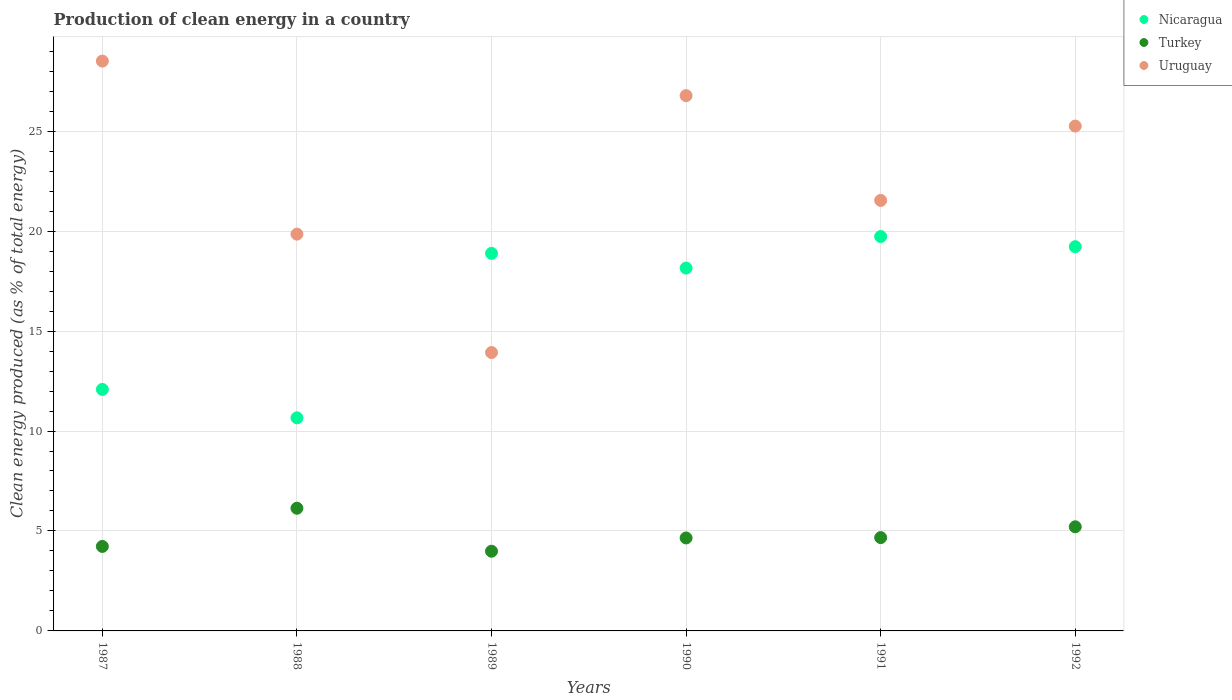Is the number of dotlines equal to the number of legend labels?
Provide a short and direct response. Yes. What is the percentage of clean energy produced in Nicaragua in 1987?
Make the answer very short. 12.08. Across all years, what is the maximum percentage of clean energy produced in Uruguay?
Your response must be concise. 28.51. Across all years, what is the minimum percentage of clean energy produced in Uruguay?
Provide a short and direct response. 13.93. In which year was the percentage of clean energy produced in Uruguay maximum?
Provide a short and direct response. 1987. In which year was the percentage of clean energy produced in Nicaragua minimum?
Give a very brief answer. 1988. What is the total percentage of clean energy produced in Uruguay in the graph?
Your answer should be very brief. 135.84. What is the difference between the percentage of clean energy produced in Nicaragua in 1989 and that in 1990?
Provide a succinct answer. 0.74. What is the difference between the percentage of clean energy produced in Nicaragua in 1990 and the percentage of clean energy produced in Uruguay in 1987?
Make the answer very short. -10.35. What is the average percentage of clean energy produced in Uruguay per year?
Make the answer very short. 22.64. In the year 1990, what is the difference between the percentage of clean energy produced in Nicaragua and percentage of clean energy produced in Uruguay?
Your answer should be very brief. -8.62. In how many years, is the percentage of clean energy produced in Turkey greater than 11 %?
Your response must be concise. 0. What is the ratio of the percentage of clean energy produced in Uruguay in 1987 to that in 1989?
Your answer should be compact. 2.05. Is the percentage of clean energy produced in Nicaragua in 1987 less than that in 1989?
Ensure brevity in your answer.  Yes. What is the difference between the highest and the second highest percentage of clean energy produced in Uruguay?
Your response must be concise. 1.73. What is the difference between the highest and the lowest percentage of clean energy produced in Turkey?
Offer a terse response. 2.15. Is it the case that in every year, the sum of the percentage of clean energy produced in Uruguay and percentage of clean energy produced in Turkey  is greater than the percentage of clean energy produced in Nicaragua?
Your answer should be compact. No. Does the percentage of clean energy produced in Nicaragua monotonically increase over the years?
Keep it short and to the point. No. Is the percentage of clean energy produced in Nicaragua strictly greater than the percentage of clean energy produced in Uruguay over the years?
Your answer should be very brief. No. Is the percentage of clean energy produced in Nicaragua strictly less than the percentage of clean energy produced in Turkey over the years?
Your response must be concise. No. Does the graph contain grids?
Provide a succinct answer. Yes. Where does the legend appear in the graph?
Provide a succinct answer. Top right. How many legend labels are there?
Provide a short and direct response. 3. What is the title of the graph?
Make the answer very short. Production of clean energy in a country. Does "Jordan" appear as one of the legend labels in the graph?
Provide a short and direct response. No. What is the label or title of the Y-axis?
Make the answer very short. Clean energy produced (as % of total energy). What is the Clean energy produced (as % of total energy) of Nicaragua in 1987?
Your answer should be compact. 12.08. What is the Clean energy produced (as % of total energy) in Turkey in 1987?
Ensure brevity in your answer.  4.23. What is the Clean energy produced (as % of total energy) in Uruguay in 1987?
Offer a very short reply. 28.51. What is the Clean energy produced (as % of total energy) in Nicaragua in 1988?
Your response must be concise. 10.66. What is the Clean energy produced (as % of total energy) in Turkey in 1988?
Your response must be concise. 6.14. What is the Clean energy produced (as % of total energy) of Uruguay in 1988?
Offer a terse response. 19.85. What is the Clean energy produced (as % of total energy) in Nicaragua in 1989?
Provide a short and direct response. 18.89. What is the Clean energy produced (as % of total energy) of Turkey in 1989?
Your answer should be compact. 3.99. What is the Clean energy produced (as % of total energy) in Uruguay in 1989?
Give a very brief answer. 13.93. What is the Clean energy produced (as % of total energy) of Nicaragua in 1990?
Offer a very short reply. 18.15. What is the Clean energy produced (as % of total energy) in Turkey in 1990?
Make the answer very short. 4.65. What is the Clean energy produced (as % of total energy) of Uruguay in 1990?
Ensure brevity in your answer.  26.78. What is the Clean energy produced (as % of total energy) in Nicaragua in 1991?
Offer a very short reply. 19.73. What is the Clean energy produced (as % of total energy) in Turkey in 1991?
Ensure brevity in your answer.  4.67. What is the Clean energy produced (as % of total energy) in Uruguay in 1991?
Your answer should be compact. 21.54. What is the Clean energy produced (as % of total energy) of Nicaragua in 1992?
Keep it short and to the point. 19.22. What is the Clean energy produced (as % of total energy) of Turkey in 1992?
Your response must be concise. 5.21. What is the Clean energy produced (as % of total energy) in Uruguay in 1992?
Ensure brevity in your answer.  25.25. Across all years, what is the maximum Clean energy produced (as % of total energy) of Nicaragua?
Your response must be concise. 19.73. Across all years, what is the maximum Clean energy produced (as % of total energy) in Turkey?
Your answer should be very brief. 6.14. Across all years, what is the maximum Clean energy produced (as % of total energy) of Uruguay?
Give a very brief answer. 28.51. Across all years, what is the minimum Clean energy produced (as % of total energy) in Nicaragua?
Your answer should be very brief. 10.66. Across all years, what is the minimum Clean energy produced (as % of total energy) in Turkey?
Provide a short and direct response. 3.99. Across all years, what is the minimum Clean energy produced (as % of total energy) of Uruguay?
Your answer should be compact. 13.93. What is the total Clean energy produced (as % of total energy) of Nicaragua in the graph?
Provide a short and direct response. 98.73. What is the total Clean energy produced (as % of total energy) of Turkey in the graph?
Provide a short and direct response. 28.88. What is the total Clean energy produced (as % of total energy) of Uruguay in the graph?
Your answer should be compact. 135.84. What is the difference between the Clean energy produced (as % of total energy) in Nicaragua in 1987 and that in 1988?
Provide a short and direct response. 1.42. What is the difference between the Clean energy produced (as % of total energy) of Turkey in 1987 and that in 1988?
Offer a terse response. -1.91. What is the difference between the Clean energy produced (as % of total energy) in Uruguay in 1987 and that in 1988?
Provide a short and direct response. 8.66. What is the difference between the Clean energy produced (as % of total energy) of Nicaragua in 1987 and that in 1989?
Offer a terse response. -6.81. What is the difference between the Clean energy produced (as % of total energy) in Turkey in 1987 and that in 1989?
Make the answer very short. 0.24. What is the difference between the Clean energy produced (as % of total energy) in Uruguay in 1987 and that in 1989?
Make the answer very short. 14.58. What is the difference between the Clean energy produced (as % of total energy) of Nicaragua in 1987 and that in 1990?
Provide a succinct answer. -6.07. What is the difference between the Clean energy produced (as % of total energy) in Turkey in 1987 and that in 1990?
Ensure brevity in your answer.  -0.42. What is the difference between the Clean energy produced (as % of total energy) of Uruguay in 1987 and that in 1990?
Keep it short and to the point. 1.73. What is the difference between the Clean energy produced (as % of total energy) in Nicaragua in 1987 and that in 1991?
Your response must be concise. -7.65. What is the difference between the Clean energy produced (as % of total energy) of Turkey in 1987 and that in 1991?
Give a very brief answer. -0.44. What is the difference between the Clean energy produced (as % of total energy) of Uruguay in 1987 and that in 1991?
Give a very brief answer. 6.97. What is the difference between the Clean energy produced (as % of total energy) in Nicaragua in 1987 and that in 1992?
Your response must be concise. -7.14. What is the difference between the Clean energy produced (as % of total energy) in Turkey in 1987 and that in 1992?
Make the answer very short. -0.98. What is the difference between the Clean energy produced (as % of total energy) of Uruguay in 1987 and that in 1992?
Provide a succinct answer. 3.25. What is the difference between the Clean energy produced (as % of total energy) in Nicaragua in 1988 and that in 1989?
Make the answer very short. -8.23. What is the difference between the Clean energy produced (as % of total energy) of Turkey in 1988 and that in 1989?
Make the answer very short. 2.15. What is the difference between the Clean energy produced (as % of total energy) in Uruguay in 1988 and that in 1989?
Your answer should be very brief. 5.92. What is the difference between the Clean energy produced (as % of total energy) in Nicaragua in 1988 and that in 1990?
Provide a succinct answer. -7.49. What is the difference between the Clean energy produced (as % of total energy) of Turkey in 1988 and that in 1990?
Your answer should be compact. 1.49. What is the difference between the Clean energy produced (as % of total energy) in Uruguay in 1988 and that in 1990?
Your answer should be compact. -6.93. What is the difference between the Clean energy produced (as % of total energy) in Nicaragua in 1988 and that in 1991?
Your answer should be very brief. -9.07. What is the difference between the Clean energy produced (as % of total energy) in Turkey in 1988 and that in 1991?
Keep it short and to the point. 1.47. What is the difference between the Clean energy produced (as % of total energy) in Uruguay in 1988 and that in 1991?
Your response must be concise. -1.69. What is the difference between the Clean energy produced (as % of total energy) of Nicaragua in 1988 and that in 1992?
Your answer should be compact. -8.56. What is the difference between the Clean energy produced (as % of total energy) in Turkey in 1988 and that in 1992?
Provide a succinct answer. 0.93. What is the difference between the Clean energy produced (as % of total energy) of Uruguay in 1988 and that in 1992?
Your answer should be compact. -5.41. What is the difference between the Clean energy produced (as % of total energy) of Nicaragua in 1989 and that in 1990?
Your answer should be very brief. 0.74. What is the difference between the Clean energy produced (as % of total energy) of Turkey in 1989 and that in 1990?
Ensure brevity in your answer.  -0.66. What is the difference between the Clean energy produced (as % of total energy) of Uruguay in 1989 and that in 1990?
Your answer should be very brief. -12.85. What is the difference between the Clean energy produced (as % of total energy) in Nicaragua in 1989 and that in 1991?
Keep it short and to the point. -0.84. What is the difference between the Clean energy produced (as % of total energy) of Turkey in 1989 and that in 1991?
Make the answer very short. -0.68. What is the difference between the Clean energy produced (as % of total energy) in Uruguay in 1989 and that in 1991?
Give a very brief answer. -7.61. What is the difference between the Clean energy produced (as % of total energy) in Nicaragua in 1989 and that in 1992?
Make the answer very short. -0.33. What is the difference between the Clean energy produced (as % of total energy) in Turkey in 1989 and that in 1992?
Your answer should be compact. -1.22. What is the difference between the Clean energy produced (as % of total energy) in Uruguay in 1989 and that in 1992?
Your response must be concise. -11.33. What is the difference between the Clean energy produced (as % of total energy) in Nicaragua in 1990 and that in 1991?
Provide a short and direct response. -1.58. What is the difference between the Clean energy produced (as % of total energy) in Turkey in 1990 and that in 1991?
Your response must be concise. -0.02. What is the difference between the Clean energy produced (as % of total energy) of Uruguay in 1990 and that in 1991?
Keep it short and to the point. 5.24. What is the difference between the Clean energy produced (as % of total energy) in Nicaragua in 1990 and that in 1992?
Make the answer very short. -1.07. What is the difference between the Clean energy produced (as % of total energy) of Turkey in 1990 and that in 1992?
Make the answer very short. -0.56. What is the difference between the Clean energy produced (as % of total energy) of Uruguay in 1990 and that in 1992?
Your response must be concise. 1.52. What is the difference between the Clean energy produced (as % of total energy) in Nicaragua in 1991 and that in 1992?
Keep it short and to the point. 0.51. What is the difference between the Clean energy produced (as % of total energy) of Turkey in 1991 and that in 1992?
Ensure brevity in your answer.  -0.54. What is the difference between the Clean energy produced (as % of total energy) of Uruguay in 1991 and that in 1992?
Your answer should be compact. -3.72. What is the difference between the Clean energy produced (as % of total energy) in Nicaragua in 1987 and the Clean energy produced (as % of total energy) in Turkey in 1988?
Give a very brief answer. 5.94. What is the difference between the Clean energy produced (as % of total energy) in Nicaragua in 1987 and the Clean energy produced (as % of total energy) in Uruguay in 1988?
Offer a very short reply. -7.77. What is the difference between the Clean energy produced (as % of total energy) in Turkey in 1987 and the Clean energy produced (as % of total energy) in Uruguay in 1988?
Make the answer very short. -15.62. What is the difference between the Clean energy produced (as % of total energy) in Nicaragua in 1987 and the Clean energy produced (as % of total energy) in Turkey in 1989?
Provide a short and direct response. 8.09. What is the difference between the Clean energy produced (as % of total energy) in Nicaragua in 1987 and the Clean energy produced (as % of total energy) in Uruguay in 1989?
Provide a short and direct response. -1.85. What is the difference between the Clean energy produced (as % of total energy) in Turkey in 1987 and the Clean energy produced (as % of total energy) in Uruguay in 1989?
Your answer should be very brief. -9.7. What is the difference between the Clean energy produced (as % of total energy) in Nicaragua in 1987 and the Clean energy produced (as % of total energy) in Turkey in 1990?
Your answer should be compact. 7.43. What is the difference between the Clean energy produced (as % of total energy) in Nicaragua in 1987 and the Clean energy produced (as % of total energy) in Uruguay in 1990?
Provide a succinct answer. -14.7. What is the difference between the Clean energy produced (as % of total energy) in Turkey in 1987 and the Clean energy produced (as % of total energy) in Uruguay in 1990?
Provide a succinct answer. -22.55. What is the difference between the Clean energy produced (as % of total energy) in Nicaragua in 1987 and the Clean energy produced (as % of total energy) in Turkey in 1991?
Provide a short and direct response. 7.41. What is the difference between the Clean energy produced (as % of total energy) in Nicaragua in 1987 and the Clean energy produced (as % of total energy) in Uruguay in 1991?
Your answer should be compact. -9.46. What is the difference between the Clean energy produced (as % of total energy) of Turkey in 1987 and the Clean energy produced (as % of total energy) of Uruguay in 1991?
Make the answer very short. -17.31. What is the difference between the Clean energy produced (as % of total energy) in Nicaragua in 1987 and the Clean energy produced (as % of total energy) in Turkey in 1992?
Offer a very short reply. 6.87. What is the difference between the Clean energy produced (as % of total energy) of Nicaragua in 1987 and the Clean energy produced (as % of total energy) of Uruguay in 1992?
Make the answer very short. -13.17. What is the difference between the Clean energy produced (as % of total energy) in Turkey in 1987 and the Clean energy produced (as % of total energy) in Uruguay in 1992?
Offer a terse response. -21.03. What is the difference between the Clean energy produced (as % of total energy) of Nicaragua in 1988 and the Clean energy produced (as % of total energy) of Turkey in 1989?
Your response must be concise. 6.67. What is the difference between the Clean energy produced (as % of total energy) in Nicaragua in 1988 and the Clean energy produced (as % of total energy) in Uruguay in 1989?
Ensure brevity in your answer.  -3.27. What is the difference between the Clean energy produced (as % of total energy) in Turkey in 1988 and the Clean energy produced (as % of total energy) in Uruguay in 1989?
Offer a very short reply. -7.79. What is the difference between the Clean energy produced (as % of total energy) in Nicaragua in 1988 and the Clean energy produced (as % of total energy) in Turkey in 1990?
Keep it short and to the point. 6.01. What is the difference between the Clean energy produced (as % of total energy) in Nicaragua in 1988 and the Clean energy produced (as % of total energy) in Uruguay in 1990?
Give a very brief answer. -16.12. What is the difference between the Clean energy produced (as % of total energy) in Turkey in 1988 and the Clean energy produced (as % of total energy) in Uruguay in 1990?
Provide a short and direct response. -20.64. What is the difference between the Clean energy produced (as % of total energy) in Nicaragua in 1988 and the Clean energy produced (as % of total energy) in Turkey in 1991?
Provide a short and direct response. 5.99. What is the difference between the Clean energy produced (as % of total energy) in Nicaragua in 1988 and the Clean energy produced (as % of total energy) in Uruguay in 1991?
Provide a succinct answer. -10.88. What is the difference between the Clean energy produced (as % of total energy) of Turkey in 1988 and the Clean energy produced (as % of total energy) of Uruguay in 1991?
Your response must be concise. -15.4. What is the difference between the Clean energy produced (as % of total energy) in Nicaragua in 1988 and the Clean energy produced (as % of total energy) in Turkey in 1992?
Ensure brevity in your answer.  5.45. What is the difference between the Clean energy produced (as % of total energy) in Nicaragua in 1988 and the Clean energy produced (as % of total energy) in Uruguay in 1992?
Offer a very short reply. -14.59. What is the difference between the Clean energy produced (as % of total energy) of Turkey in 1988 and the Clean energy produced (as % of total energy) of Uruguay in 1992?
Your response must be concise. -19.12. What is the difference between the Clean energy produced (as % of total energy) of Nicaragua in 1989 and the Clean energy produced (as % of total energy) of Turkey in 1990?
Provide a short and direct response. 14.24. What is the difference between the Clean energy produced (as % of total energy) of Nicaragua in 1989 and the Clean energy produced (as % of total energy) of Uruguay in 1990?
Make the answer very short. -7.89. What is the difference between the Clean energy produced (as % of total energy) of Turkey in 1989 and the Clean energy produced (as % of total energy) of Uruguay in 1990?
Offer a terse response. -22.79. What is the difference between the Clean energy produced (as % of total energy) in Nicaragua in 1989 and the Clean energy produced (as % of total energy) in Turkey in 1991?
Ensure brevity in your answer.  14.22. What is the difference between the Clean energy produced (as % of total energy) of Nicaragua in 1989 and the Clean energy produced (as % of total energy) of Uruguay in 1991?
Your answer should be compact. -2.65. What is the difference between the Clean energy produced (as % of total energy) in Turkey in 1989 and the Clean energy produced (as % of total energy) in Uruguay in 1991?
Your answer should be compact. -17.55. What is the difference between the Clean energy produced (as % of total energy) in Nicaragua in 1989 and the Clean energy produced (as % of total energy) in Turkey in 1992?
Offer a very short reply. 13.68. What is the difference between the Clean energy produced (as % of total energy) in Nicaragua in 1989 and the Clean energy produced (as % of total energy) in Uruguay in 1992?
Ensure brevity in your answer.  -6.37. What is the difference between the Clean energy produced (as % of total energy) in Turkey in 1989 and the Clean energy produced (as % of total energy) in Uruguay in 1992?
Your answer should be compact. -21.27. What is the difference between the Clean energy produced (as % of total energy) of Nicaragua in 1990 and the Clean energy produced (as % of total energy) of Turkey in 1991?
Your answer should be very brief. 13.48. What is the difference between the Clean energy produced (as % of total energy) of Nicaragua in 1990 and the Clean energy produced (as % of total energy) of Uruguay in 1991?
Ensure brevity in your answer.  -3.38. What is the difference between the Clean energy produced (as % of total energy) of Turkey in 1990 and the Clean energy produced (as % of total energy) of Uruguay in 1991?
Your answer should be compact. -16.88. What is the difference between the Clean energy produced (as % of total energy) in Nicaragua in 1990 and the Clean energy produced (as % of total energy) in Turkey in 1992?
Offer a terse response. 12.94. What is the difference between the Clean energy produced (as % of total energy) in Nicaragua in 1990 and the Clean energy produced (as % of total energy) in Uruguay in 1992?
Your answer should be very brief. -7.1. What is the difference between the Clean energy produced (as % of total energy) of Turkey in 1990 and the Clean energy produced (as % of total energy) of Uruguay in 1992?
Offer a very short reply. -20.6. What is the difference between the Clean energy produced (as % of total energy) of Nicaragua in 1991 and the Clean energy produced (as % of total energy) of Turkey in 1992?
Keep it short and to the point. 14.52. What is the difference between the Clean energy produced (as % of total energy) of Nicaragua in 1991 and the Clean energy produced (as % of total energy) of Uruguay in 1992?
Your answer should be very brief. -5.52. What is the difference between the Clean energy produced (as % of total energy) of Turkey in 1991 and the Clean energy produced (as % of total energy) of Uruguay in 1992?
Keep it short and to the point. -20.59. What is the average Clean energy produced (as % of total energy) of Nicaragua per year?
Your answer should be very brief. 16.45. What is the average Clean energy produced (as % of total energy) of Turkey per year?
Your answer should be compact. 4.81. What is the average Clean energy produced (as % of total energy) in Uruguay per year?
Give a very brief answer. 22.64. In the year 1987, what is the difference between the Clean energy produced (as % of total energy) of Nicaragua and Clean energy produced (as % of total energy) of Turkey?
Provide a succinct answer. 7.85. In the year 1987, what is the difference between the Clean energy produced (as % of total energy) of Nicaragua and Clean energy produced (as % of total energy) of Uruguay?
Offer a very short reply. -16.43. In the year 1987, what is the difference between the Clean energy produced (as % of total energy) in Turkey and Clean energy produced (as % of total energy) in Uruguay?
Provide a succinct answer. -24.28. In the year 1988, what is the difference between the Clean energy produced (as % of total energy) in Nicaragua and Clean energy produced (as % of total energy) in Turkey?
Give a very brief answer. 4.52. In the year 1988, what is the difference between the Clean energy produced (as % of total energy) of Nicaragua and Clean energy produced (as % of total energy) of Uruguay?
Provide a short and direct response. -9.19. In the year 1988, what is the difference between the Clean energy produced (as % of total energy) in Turkey and Clean energy produced (as % of total energy) in Uruguay?
Offer a very short reply. -13.71. In the year 1989, what is the difference between the Clean energy produced (as % of total energy) in Nicaragua and Clean energy produced (as % of total energy) in Turkey?
Your response must be concise. 14.9. In the year 1989, what is the difference between the Clean energy produced (as % of total energy) of Nicaragua and Clean energy produced (as % of total energy) of Uruguay?
Your answer should be very brief. 4.96. In the year 1989, what is the difference between the Clean energy produced (as % of total energy) of Turkey and Clean energy produced (as % of total energy) of Uruguay?
Give a very brief answer. -9.94. In the year 1990, what is the difference between the Clean energy produced (as % of total energy) of Nicaragua and Clean energy produced (as % of total energy) of Turkey?
Offer a very short reply. 13.5. In the year 1990, what is the difference between the Clean energy produced (as % of total energy) of Nicaragua and Clean energy produced (as % of total energy) of Uruguay?
Give a very brief answer. -8.62. In the year 1990, what is the difference between the Clean energy produced (as % of total energy) of Turkey and Clean energy produced (as % of total energy) of Uruguay?
Give a very brief answer. -22.13. In the year 1991, what is the difference between the Clean energy produced (as % of total energy) of Nicaragua and Clean energy produced (as % of total energy) of Turkey?
Your response must be concise. 15.06. In the year 1991, what is the difference between the Clean energy produced (as % of total energy) of Nicaragua and Clean energy produced (as % of total energy) of Uruguay?
Provide a succinct answer. -1.81. In the year 1991, what is the difference between the Clean energy produced (as % of total energy) of Turkey and Clean energy produced (as % of total energy) of Uruguay?
Offer a terse response. -16.87. In the year 1992, what is the difference between the Clean energy produced (as % of total energy) of Nicaragua and Clean energy produced (as % of total energy) of Turkey?
Give a very brief answer. 14.01. In the year 1992, what is the difference between the Clean energy produced (as % of total energy) of Nicaragua and Clean energy produced (as % of total energy) of Uruguay?
Your answer should be very brief. -6.03. In the year 1992, what is the difference between the Clean energy produced (as % of total energy) in Turkey and Clean energy produced (as % of total energy) in Uruguay?
Your answer should be compact. -20.04. What is the ratio of the Clean energy produced (as % of total energy) of Nicaragua in 1987 to that in 1988?
Ensure brevity in your answer.  1.13. What is the ratio of the Clean energy produced (as % of total energy) in Turkey in 1987 to that in 1988?
Provide a succinct answer. 0.69. What is the ratio of the Clean energy produced (as % of total energy) of Uruguay in 1987 to that in 1988?
Your answer should be very brief. 1.44. What is the ratio of the Clean energy produced (as % of total energy) of Nicaragua in 1987 to that in 1989?
Your answer should be very brief. 0.64. What is the ratio of the Clean energy produced (as % of total energy) in Turkey in 1987 to that in 1989?
Offer a terse response. 1.06. What is the ratio of the Clean energy produced (as % of total energy) of Uruguay in 1987 to that in 1989?
Ensure brevity in your answer.  2.05. What is the ratio of the Clean energy produced (as % of total energy) of Nicaragua in 1987 to that in 1990?
Offer a very short reply. 0.67. What is the ratio of the Clean energy produced (as % of total energy) of Turkey in 1987 to that in 1990?
Provide a short and direct response. 0.91. What is the ratio of the Clean energy produced (as % of total energy) of Uruguay in 1987 to that in 1990?
Keep it short and to the point. 1.06. What is the ratio of the Clean energy produced (as % of total energy) in Nicaragua in 1987 to that in 1991?
Make the answer very short. 0.61. What is the ratio of the Clean energy produced (as % of total energy) in Turkey in 1987 to that in 1991?
Keep it short and to the point. 0.91. What is the ratio of the Clean energy produced (as % of total energy) in Uruguay in 1987 to that in 1991?
Ensure brevity in your answer.  1.32. What is the ratio of the Clean energy produced (as % of total energy) in Nicaragua in 1987 to that in 1992?
Offer a very short reply. 0.63. What is the ratio of the Clean energy produced (as % of total energy) of Turkey in 1987 to that in 1992?
Keep it short and to the point. 0.81. What is the ratio of the Clean energy produced (as % of total energy) in Uruguay in 1987 to that in 1992?
Your response must be concise. 1.13. What is the ratio of the Clean energy produced (as % of total energy) in Nicaragua in 1988 to that in 1989?
Your response must be concise. 0.56. What is the ratio of the Clean energy produced (as % of total energy) of Turkey in 1988 to that in 1989?
Provide a short and direct response. 1.54. What is the ratio of the Clean energy produced (as % of total energy) of Uruguay in 1988 to that in 1989?
Your answer should be very brief. 1.43. What is the ratio of the Clean energy produced (as % of total energy) in Nicaragua in 1988 to that in 1990?
Provide a short and direct response. 0.59. What is the ratio of the Clean energy produced (as % of total energy) in Turkey in 1988 to that in 1990?
Give a very brief answer. 1.32. What is the ratio of the Clean energy produced (as % of total energy) of Uruguay in 1988 to that in 1990?
Make the answer very short. 0.74. What is the ratio of the Clean energy produced (as % of total energy) of Nicaragua in 1988 to that in 1991?
Your response must be concise. 0.54. What is the ratio of the Clean energy produced (as % of total energy) of Turkey in 1988 to that in 1991?
Your response must be concise. 1.31. What is the ratio of the Clean energy produced (as % of total energy) in Uruguay in 1988 to that in 1991?
Offer a terse response. 0.92. What is the ratio of the Clean energy produced (as % of total energy) in Nicaragua in 1988 to that in 1992?
Make the answer very short. 0.55. What is the ratio of the Clean energy produced (as % of total energy) of Turkey in 1988 to that in 1992?
Ensure brevity in your answer.  1.18. What is the ratio of the Clean energy produced (as % of total energy) of Uruguay in 1988 to that in 1992?
Provide a short and direct response. 0.79. What is the ratio of the Clean energy produced (as % of total energy) of Nicaragua in 1989 to that in 1990?
Provide a short and direct response. 1.04. What is the ratio of the Clean energy produced (as % of total energy) in Turkey in 1989 to that in 1990?
Make the answer very short. 0.86. What is the ratio of the Clean energy produced (as % of total energy) of Uruguay in 1989 to that in 1990?
Your answer should be compact. 0.52. What is the ratio of the Clean energy produced (as % of total energy) in Nicaragua in 1989 to that in 1991?
Your response must be concise. 0.96. What is the ratio of the Clean energy produced (as % of total energy) of Turkey in 1989 to that in 1991?
Offer a very short reply. 0.85. What is the ratio of the Clean energy produced (as % of total energy) of Uruguay in 1989 to that in 1991?
Provide a short and direct response. 0.65. What is the ratio of the Clean energy produced (as % of total energy) in Nicaragua in 1989 to that in 1992?
Offer a very short reply. 0.98. What is the ratio of the Clean energy produced (as % of total energy) in Turkey in 1989 to that in 1992?
Give a very brief answer. 0.77. What is the ratio of the Clean energy produced (as % of total energy) in Uruguay in 1989 to that in 1992?
Your answer should be compact. 0.55. What is the ratio of the Clean energy produced (as % of total energy) of Turkey in 1990 to that in 1991?
Your answer should be very brief. 1. What is the ratio of the Clean energy produced (as % of total energy) in Uruguay in 1990 to that in 1991?
Ensure brevity in your answer.  1.24. What is the ratio of the Clean energy produced (as % of total energy) in Turkey in 1990 to that in 1992?
Offer a very short reply. 0.89. What is the ratio of the Clean energy produced (as % of total energy) in Uruguay in 1990 to that in 1992?
Your answer should be compact. 1.06. What is the ratio of the Clean energy produced (as % of total energy) in Nicaragua in 1991 to that in 1992?
Offer a terse response. 1.03. What is the ratio of the Clean energy produced (as % of total energy) of Turkey in 1991 to that in 1992?
Offer a very short reply. 0.9. What is the ratio of the Clean energy produced (as % of total energy) in Uruguay in 1991 to that in 1992?
Make the answer very short. 0.85. What is the difference between the highest and the second highest Clean energy produced (as % of total energy) in Nicaragua?
Give a very brief answer. 0.51. What is the difference between the highest and the second highest Clean energy produced (as % of total energy) in Turkey?
Provide a short and direct response. 0.93. What is the difference between the highest and the second highest Clean energy produced (as % of total energy) of Uruguay?
Ensure brevity in your answer.  1.73. What is the difference between the highest and the lowest Clean energy produced (as % of total energy) in Nicaragua?
Offer a very short reply. 9.07. What is the difference between the highest and the lowest Clean energy produced (as % of total energy) in Turkey?
Offer a terse response. 2.15. What is the difference between the highest and the lowest Clean energy produced (as % of total energy) in Uruguay?
Give a very brief answer. 14.58. 